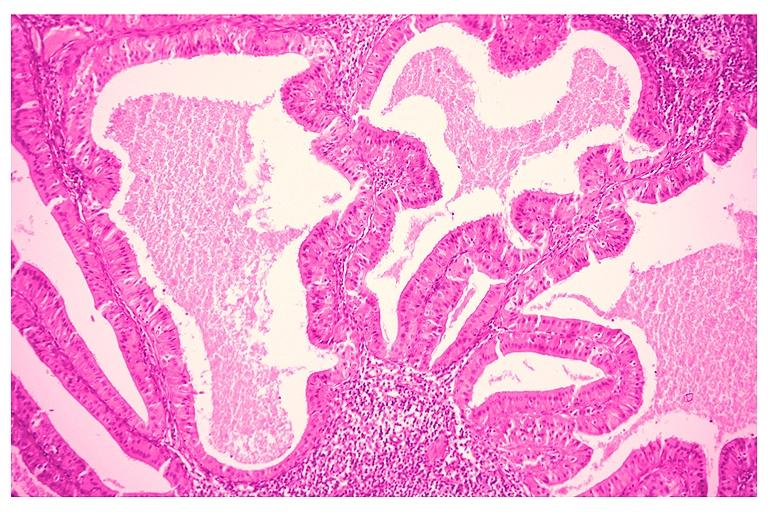what is present?
Answer the question using a single word or phrase. Oral 